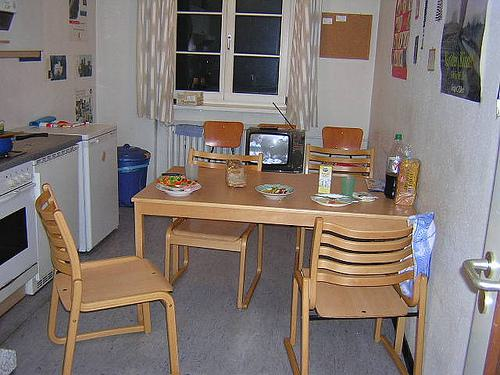Describe the meal that is set on the table. On the table, there appears to be a meal consisting of bowls containing food, a plate with bread, and drinks, suggesting that the table is set for a simple, yet nourishing meal. 